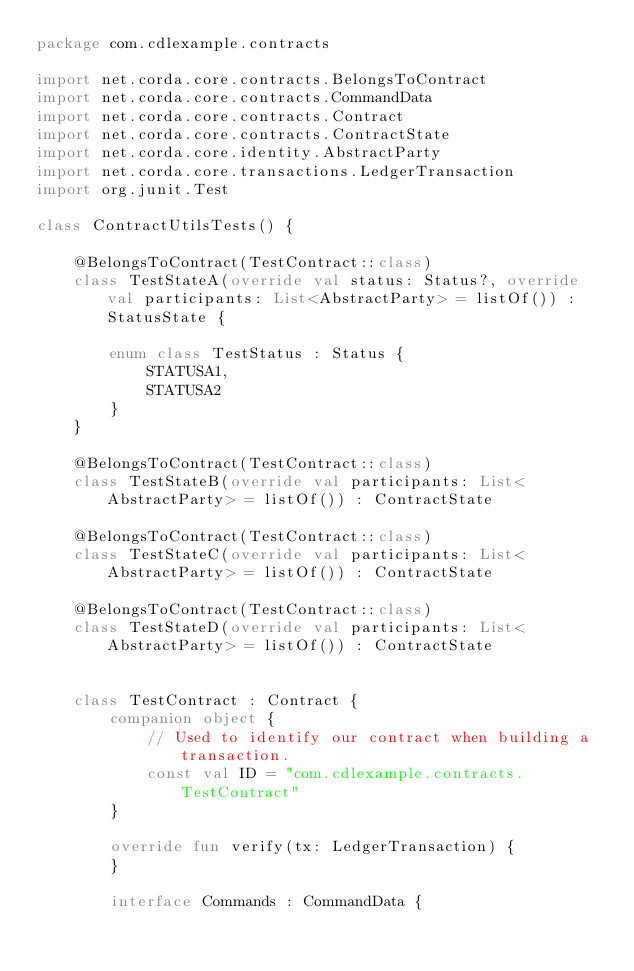Convert code to text. <code><loc_0><loc_0><loc_500><loc_500><_Kotlin_>package com.cdlexample.contracts

import net.corda.core.contracts.BelongsToContract
import net.corda.core.contracts.CommandData
import net.corda.core.contracts.Contract
import net.corda.core.contracts.ContractState
import net.corda.core.identity.AbstractParty
import net.corda.core.transactions.LedgerTransaction
import org.junit.Test

class ContractUtilsTests() {

    @BelongsToContract(TestContract::class)
    class TestStateA(override val status: Status?, override val participants: List<AbstractParty> = listOf()) : StatusState {

        enum class TestStatus : Status {
            STATUSA1,
            STATUSA2
        }
    }

    @BelongsToContract(TestContract::class)
    class TestStateB(override val participants: List<AbstractParty> = listOf()) : ContractState

    @BelongsToContract(TestContract::class)
    class TestStateC(override val participants: List<AbstractParty> = listOf()) : ContractState

    @BelongsToContract(TestContract::class)
    class TestStateD(override val participants: List<AbstractParty> = listOf()) : ContractState


    class TestContract : Contract {
        companion object {
            // Used to identify our contract when building a transaction.
            const val ID = "com.cdlexample.contracts.TestContract"
        }

        override fun verify(tx: LedgerTransaction) {
        }

        interface Commands : CommandData {</code> 